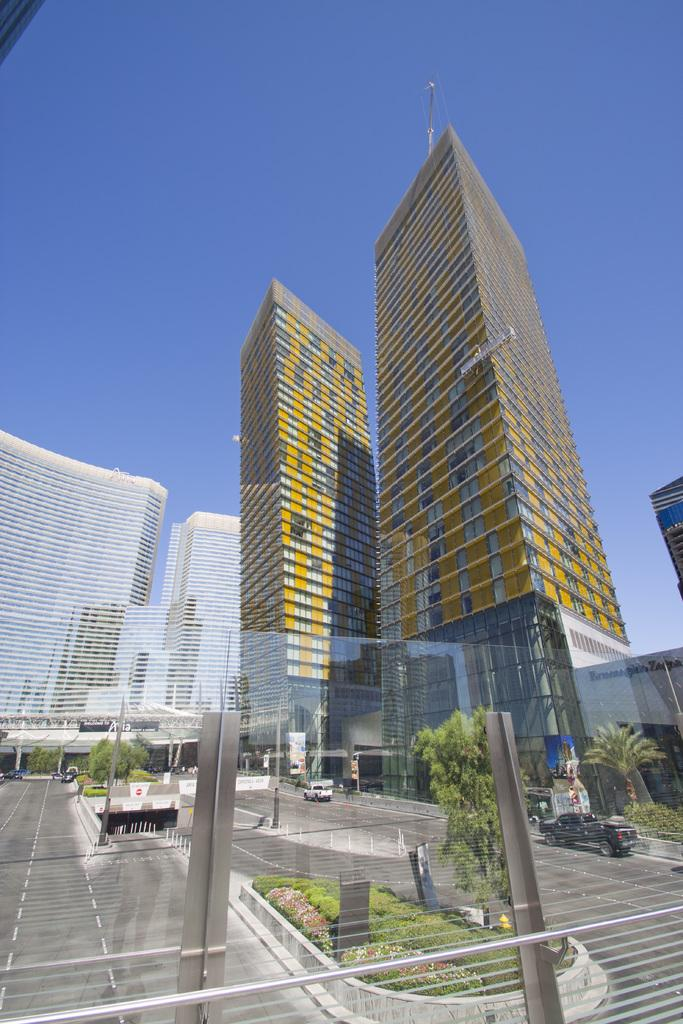What type of structures can be seen in the image? There are buildings in the image. What natural elements are present in the image? There are trees in the image. What man-made feature connects two areas in the image? There is a bridge in the image. What part of the natural environment is visible in the image? The sky is visible in the image. What type of transportation is present in the image? There are vehicles on the road in the image. What type of fencing is present in the image? There is glass fencing in the image. What advice does the manager give to the uncle's brain in the image? There is no mention of a manager, uncle, or brain in the image; it features buildings, trees, a bridge, the sky, vehicles, and glass fencing. 